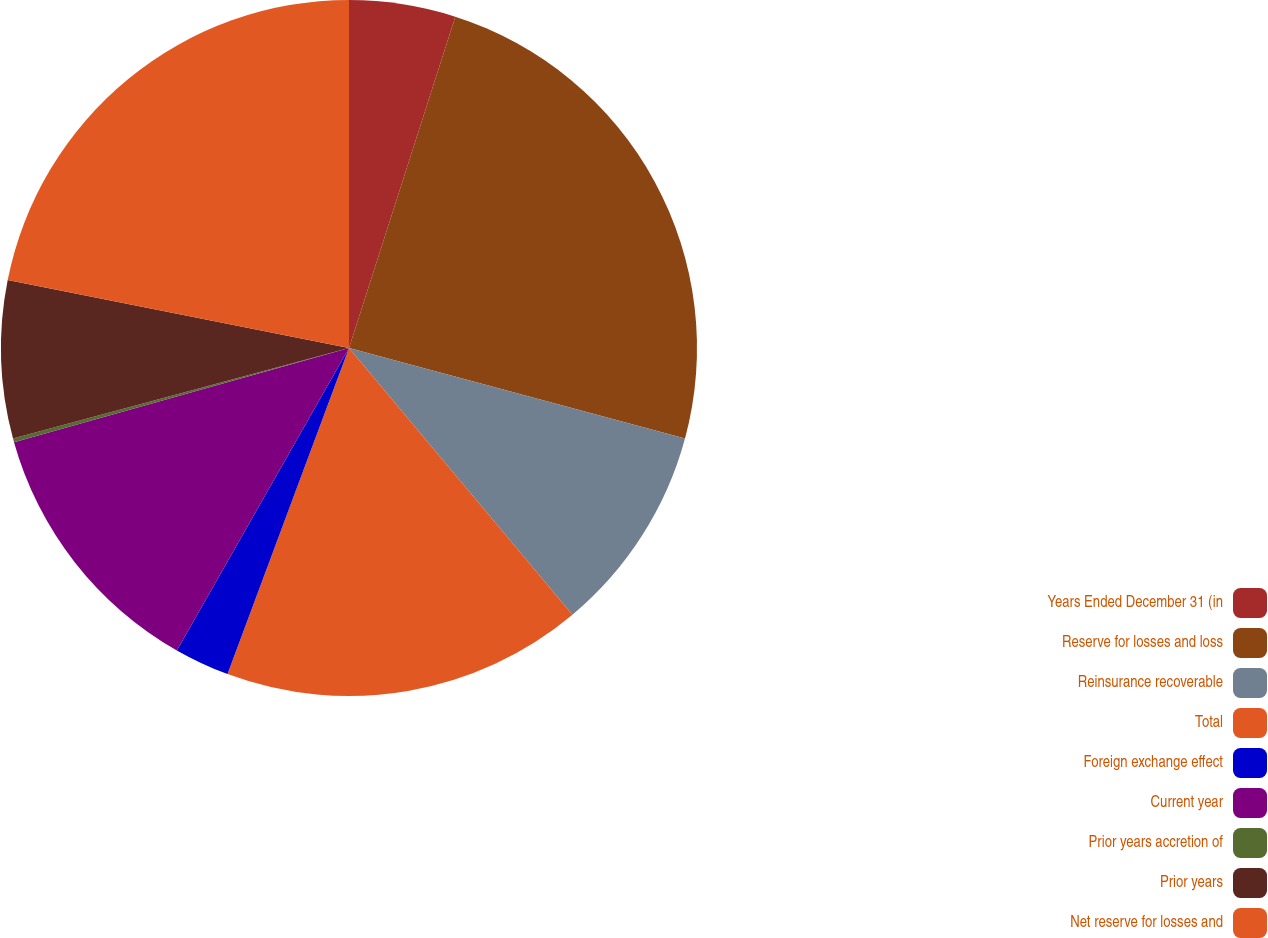Convert chart to OTSL. <chart><loc_0><loc_0><loc_500><loc_500><pie_chart><fcel>Years Ended December 31 (in<fcel>Reserve for losses and loss<fcel>Reinsurance recoverable<fcel>Total<fcel>Foreign exchange effect<fcel>Current year<fcel>Prior years accretion of<fcel>Prior years<fcel>Net reserve for losses and<nl><fcel>4.94%<fcel>24.25%<fcel>9.71%<fcel>16.77%<fcel>2.56%<fcel>12.4%<fcel>0.17%<fcel>7.32%<fcel>21.87%<nl></chart> 